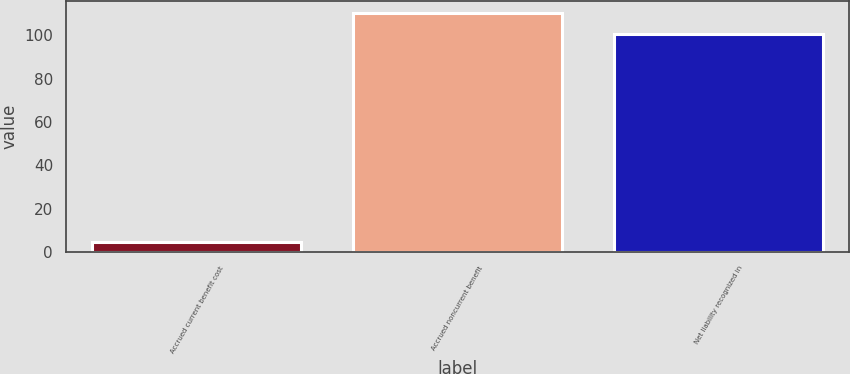<chart> <loc_0><loc_0><loc_500><loc_500><bar_chart><fcel>Accrued current benefit cost<fcel>Accrued noncurrent benefit<fcel>Net liability recognized in<nl><fcel>4.4<fcel>110.37<fcel>100.7<nl></chart> 